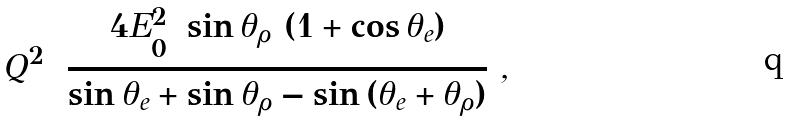Convert formula to latex. <formula><loc_0><loc_0><loc_500><loc_500>Q ^ { 2 } = \frac { 4 E _ { 0 } ^ { 2 } \ \sin { \theta _ { \rho } } \ ( 1 + \cos { \theta _ { e } } ) } { \sin { \theta _ { e } } + \sin { \theta _ { \rho } } - \sin { ( \theta _ { e } + \theta _ { \rho } ) } } \ ,</formula> 